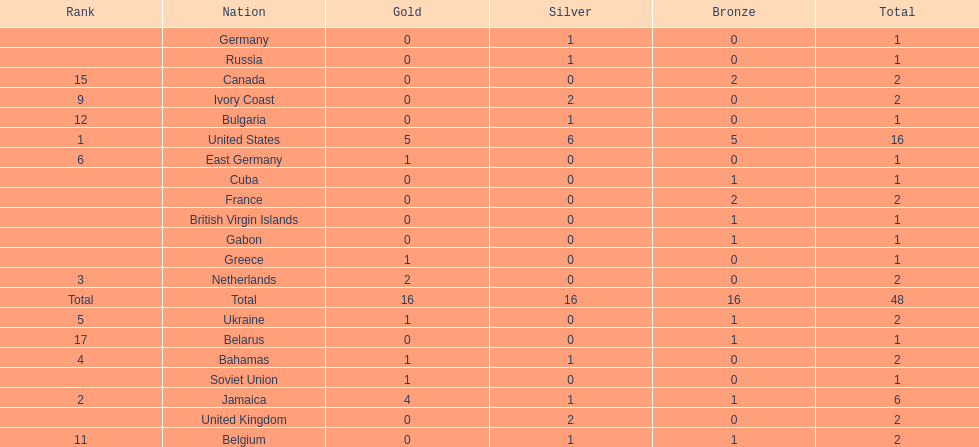After the united states, what country won the most gold medals. Jamaica. 